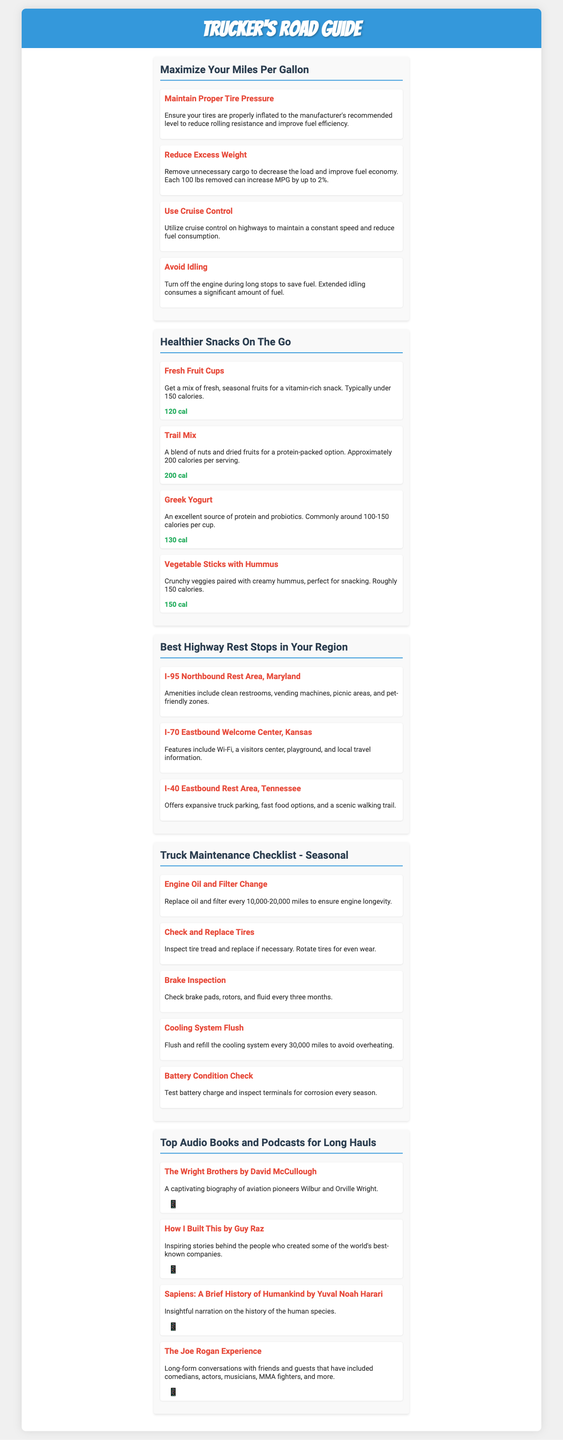What is the recommended increase in MPG by removing 100 lbs? The document states that each 100 lbs removed can increase MPG by up to 2%.
Answer: 2% What is a tip for improving fuel efficiency related to tire pressure? The document advises maintaining proper tire pressure to reduce rolling resistance and improve fuel efficiency.
Answer: Proper Tire Pressure How many calories are in Vegetable Sticks with Hummus? The calorie count for Vegetable Sticks with Hummus is mentioned in the document.
Answer: 150 cal Which rest area features Wi-Fi and a playground? The document specifically states that I-70 Eastbound Welcome Center in Kansas features Wi-Fi and a playground.
Answer: I-70 Eastbound Welcome Center, Kansas What maintenance task should be done every three months? The document lists brake inspection as a task that should be checked every three months.
Answer: Brake Inspection Name a book recommended for long hauls. The document recommends "The Wright Brothers" by David McCullough for long hauls.
Answer: The Wright Brothers What is one item you can find in a truck maintenance checklist? The document provides various tasks, one being the engine oil and filter change.
Answer: Engine Oil and Filter Change What type of content does the flyer suggest for entertainment on the road? The document suggests audiobooks and podcasts as entertainment options for long hauls.
Answer: Audiobooks and Podcasts What is the purpose of the flyer? The document serves as a guide tailored for truckers including tips, snack options, rest stop locations, maintenance tasks, and entertainment suggestions.
Answer: Trucker's Road Guide 